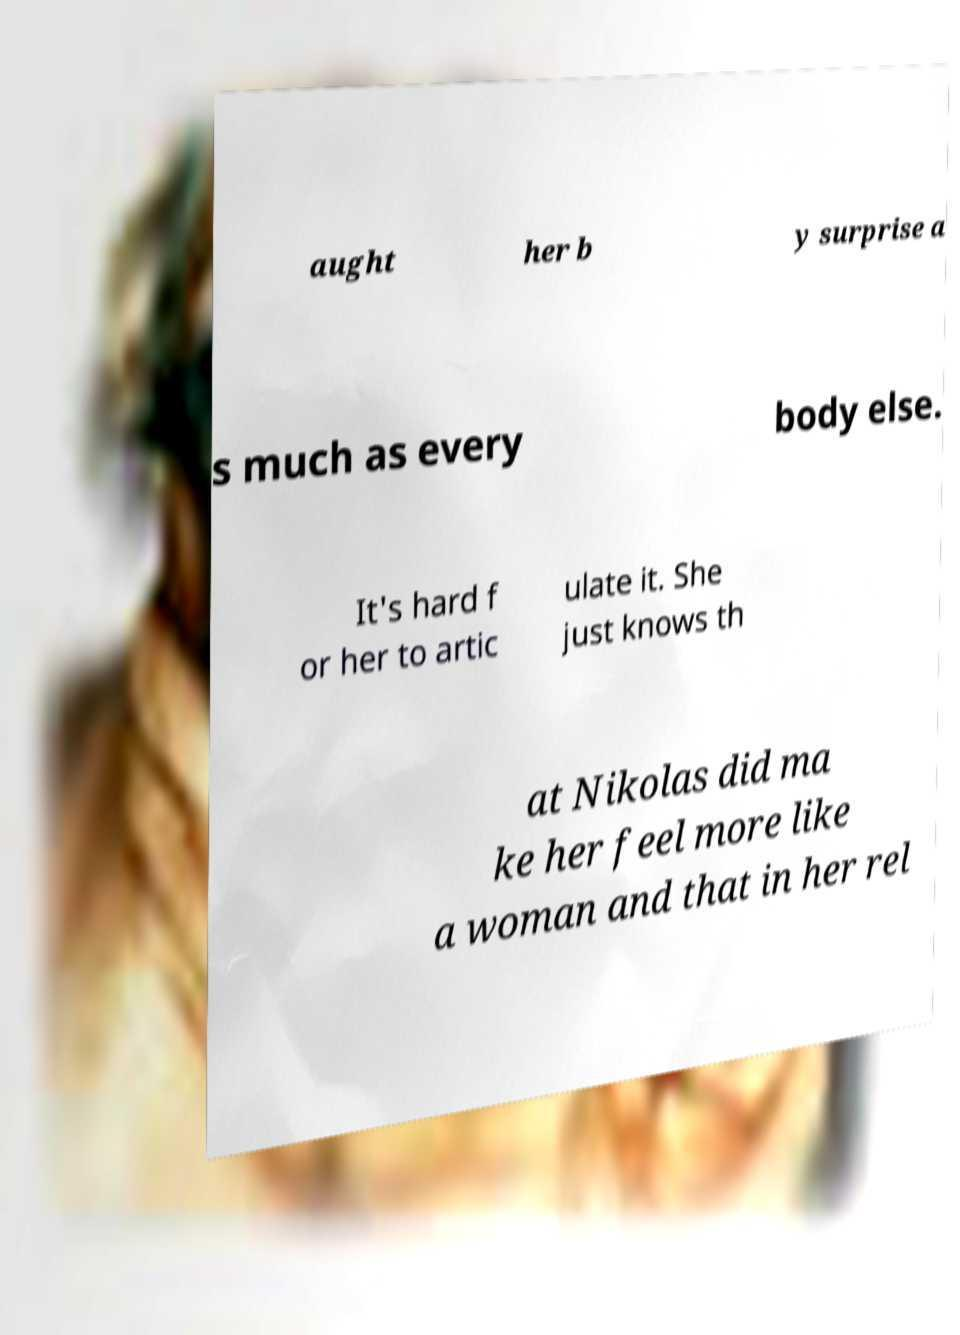Can you accurately transcribe the text from the provided image for me? aught her b y surprise a s much as every body else. It's hard f or her to artic ulate it. She just knows th at Nikolas did ma ke her feel more like a woman and that in her rel 